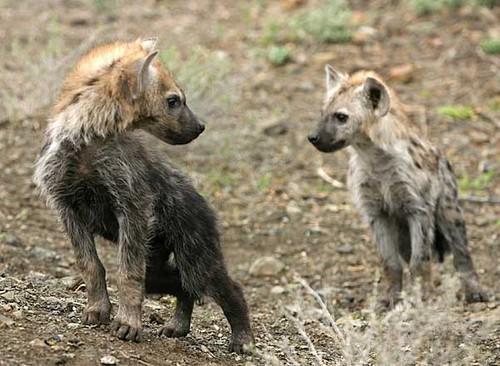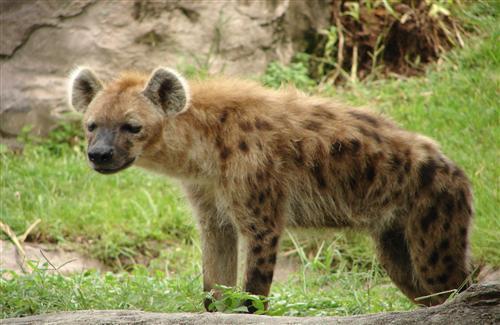The first image is the image on the left, the second image is the image on the right. For the images shown, is this caption "In one of the images, there is one hyena with its mouth open bearing its teeth" true? Answer yes or no. No. 